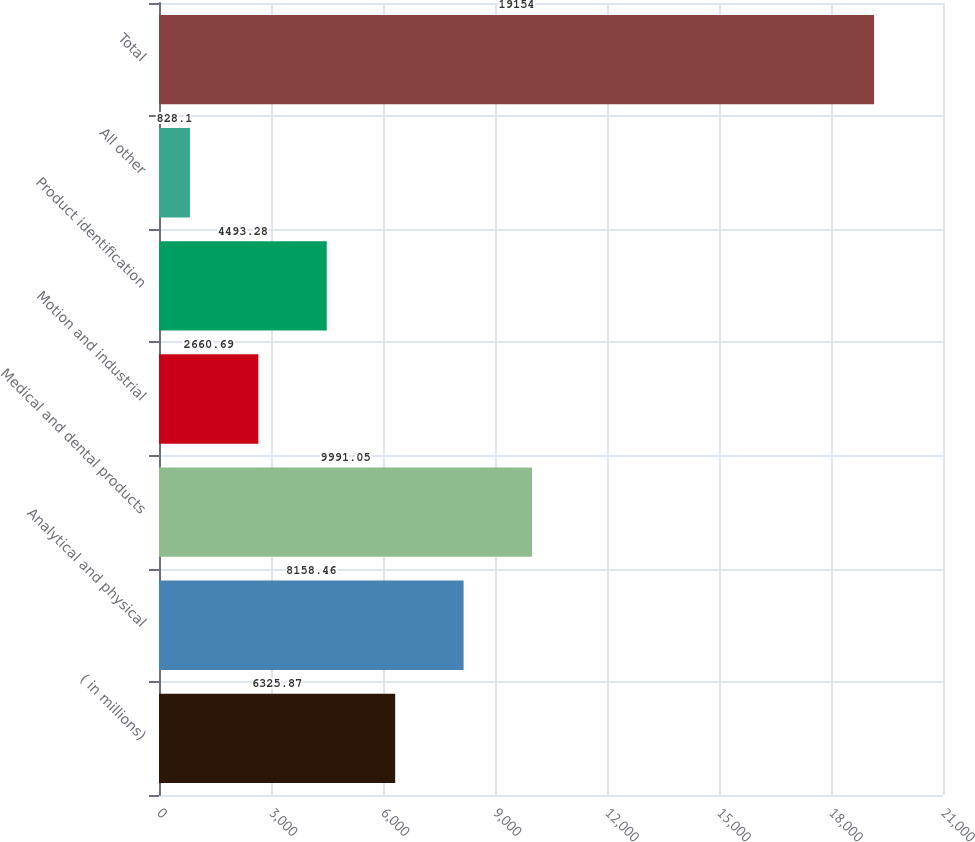<chart> <loc_0><loc_0><loc_500><loc_500><bar_chart><fcel>( in millions)<fcel>Analytical and physical<fcel>Medical and dental products<fcel>Motion and industrial<fcel>Product identification<fcel>All other<fcel>Total<nl><fcel>6325.87<fcel>8158.46<fcel>9991.05<fcel>2660.69<fcel>4493.28<fcel>828.1<fcel>19154<nl></chart> 